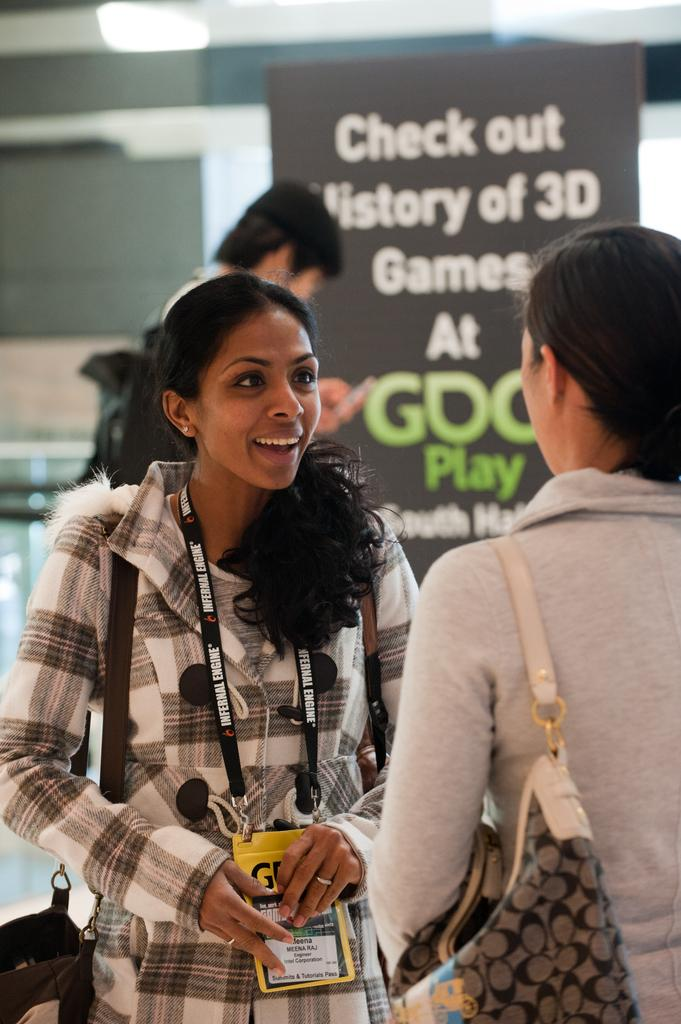How many people are in the image? There are three persons in the image. What is one of the persons holding? One of the persons is holding a cell phone. What are the two ladies carrying? The two ladies are carrying bags. What can be seen on the board in the image? There is a board with text in the image. What type of structure is present in the image? There is a wall in the image. What is the source of illumination in the image? There is a light in the image. What type of powder is being used by the person holding the cell phone in the image? There is no powder present in the image, and the person holding the cell phone is not using any powder. 